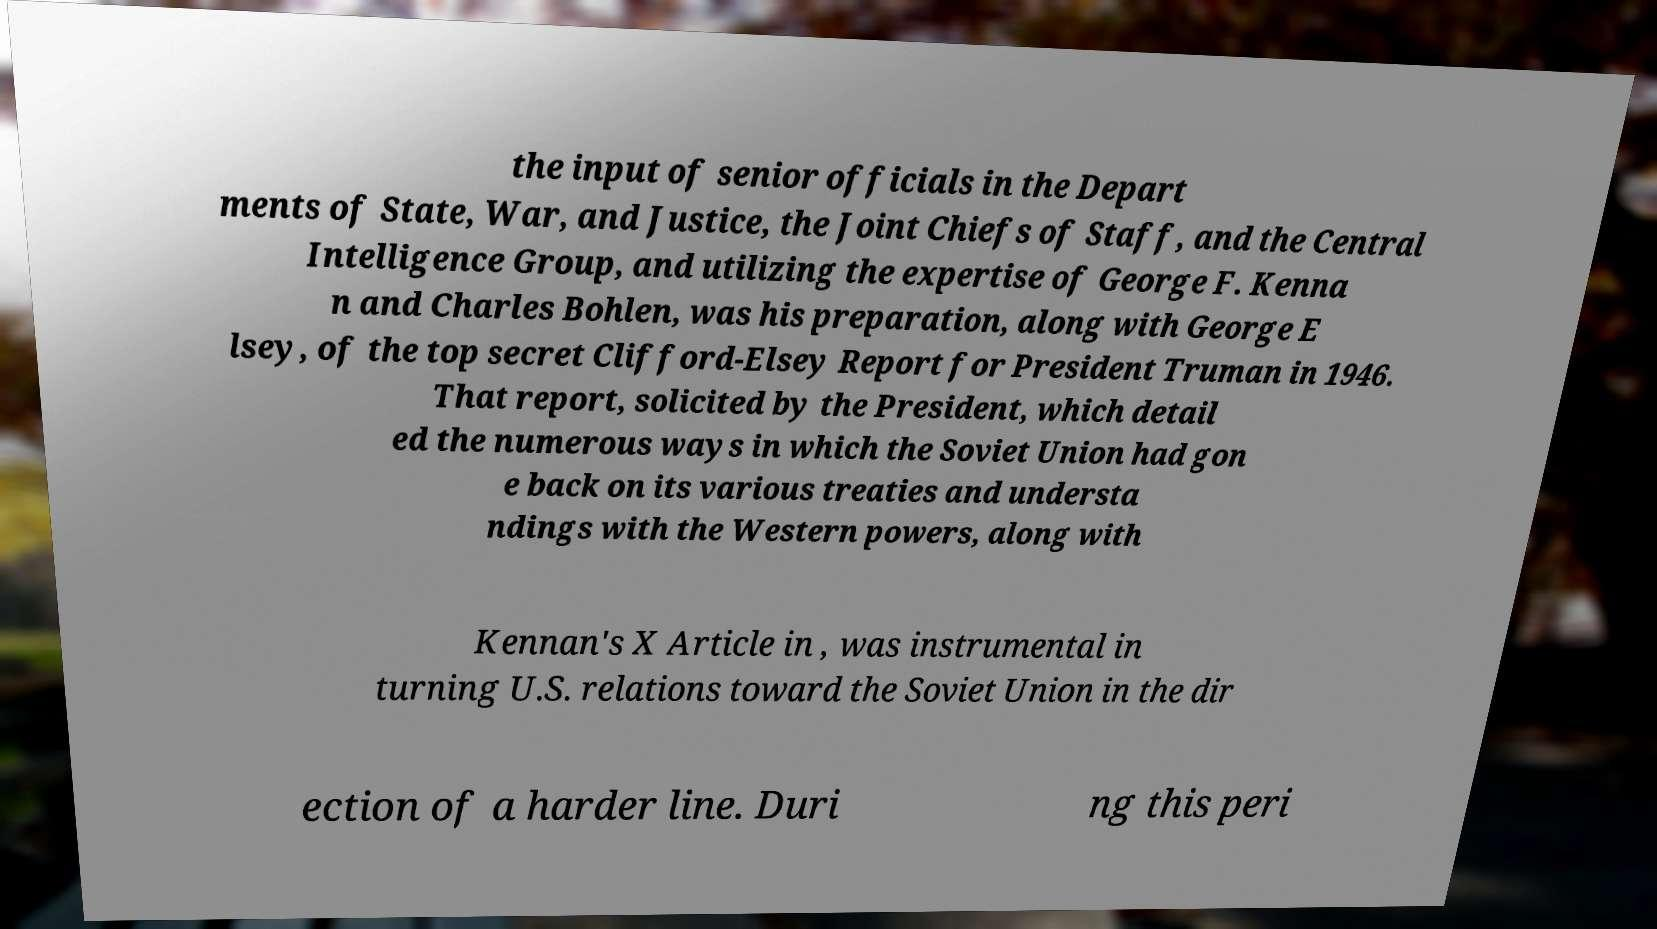For documentation purposes, I need the text within this image transcribed. Could you provide that? the input of senior officials in the Depart ments of State, War, and Justice, the Joint Chiefs of Staff, and the Central Intelligence Group, and utilizing the expertise of George F. Kenna n and Charles Bohlen, was his preparation, along with George E lsey, of the top secret Clifford-Elsey Report for President Truman in 1946. That report, solicited by the President, which detail ed the numerous ways in which the Soviet Union had gon e back on its various treaties and understa ndings with the Western powers, along with Kennan's X Article in , was instrumental in turning U.S. relations toward the Soviet Union in the dir ection of a harder line. Duri ng this peri 